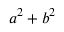Convert formula to latex. <formula><loc_0><loc_0><loc_500><loc_500>a ^ { 2 } + b ^ { 2 }</formula> 